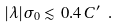Convert formula to latex. <formula><loc_0><loc_0><loc_500><loc_500>| \lambda | \sigma _ { 0 } \lesssim 0 . 4 \, C ^ { \prime } \ .</formula> 